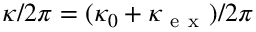Convert formula to latex. <formula><loc_0><loc_0><loc_500><loc_500>\kappa / 2 \pi = ( \kappa _ { 0 } + \kappa _ { e x } ) / 2 \pi</formula> 